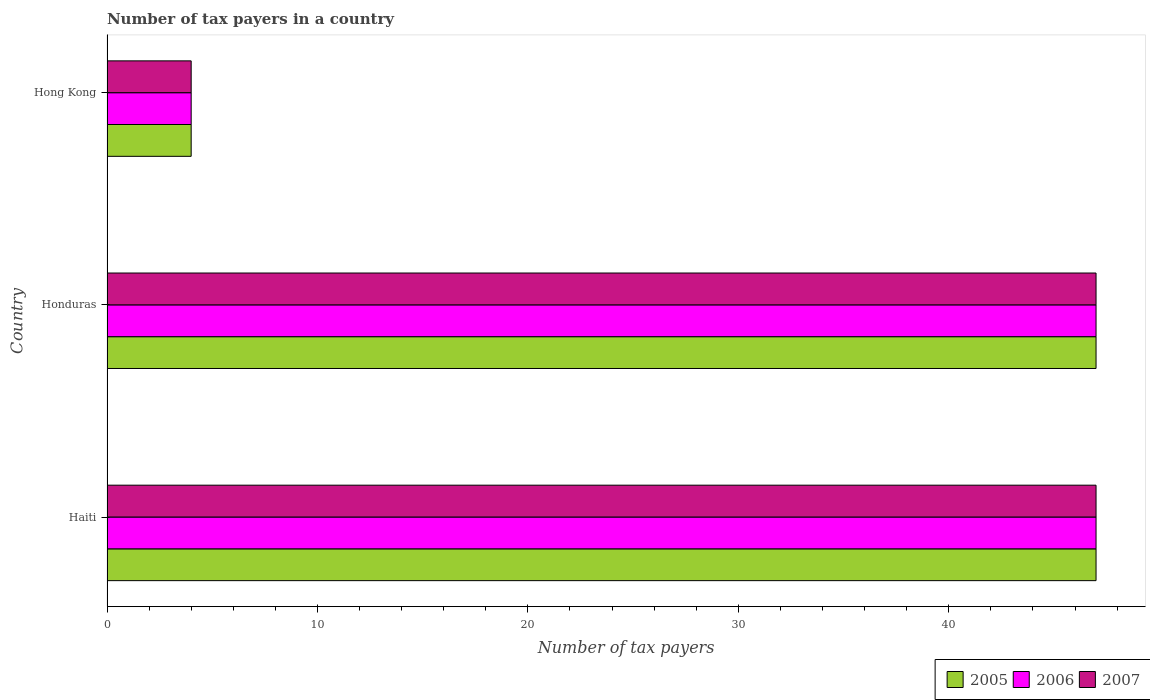How many groups of bars are there?
Provide a short and direct response. 3. Are the number of bars on each tick of the Y-axis equal?
Your answer should be very brief. Yes. How many bars are there on the 1st tick from the top?
Give a very brief answer. 3. How many bars are there on the 1st tick from the bottom?
Keep it short and to the point. 3. What is the label of the 2nd group of bars from the top?
Make the answer very short. Honduras. In how many cases, is the number of bars for a given country not equal to the number of legend labels?
Provide a succinct answer. 0. Across all countries, what is the maximum number of tax payers in in 2006?
Your answer should be very brief. 47. Across all countries, what is the minimum number of tax payers in in 2005?
Offer a very short reply. 4. In which country was the number of tax payers in in 2007 maximum?
Your answer should be compact. Haiti. In which country was the number of tax payers in in 2006 minimum?
Keep it short and to the point. Hong Kong. What is the difference between the number of tax payers in in 2006 in Haiti and that in Hong Kong?
Make the answer very short. 43. What is the difference between the number of tax payers in in 2006 in Hong Kong and the number of tax payers in in 2005 in Haiti?
Your answer should be very brief. -43. What is the average number of tax payers in in 2005 per country?
Offer a very short reply. 32.67. What is the difference between the number of tax payers in in 2006 and number of tax payers in in 2007 in Haiti?
Keep it short and to the point. 0. In how many countries, is the number of tax payers in in 2007 greater than 28 ?
Ensure brevity in your answer.  2. What is the ratio of the number of tax payers in in 2007 in Haiti to that in Hong Kong?
Your answer should be compact. 11.75. Is the number of tax payers in in 2006 in Honduras less than that in Hong Kong?
Offer a very short reply. No. Is the difference between the number of tax payers in in 2006 in Honduras and Hong Kong greater than the difference between the number of tax payers in in 2007 in Honduras and Hong Kong?
Ensure brevity in your answer.  No. What is the difference between the highest and the second highest number of tax payers in in 2005?
Your answer should be very brief. 0. Is it the case that in every country, the sum of the number of tax payers in in 2006 and number of tax payers in in 2007 is greater than the number of tax payers in in 2005?
Offer a very short reply. Yes. Are all the bars in the graph horizontal?
Give a very brief answer. Yes. What is the difference between two consecutive major ticks on the X-axis?
Offer a terse response. 10. Are the values on the major ticks of X-axis written in scientific E-notation?
Provide a succinct answer. No. Does the graph contain any zero values?
Keep it short and to the point. No. Where does the legend appear in the graph?
Offer a very short reply. Bottom right. What is the title of the graph?
Provide a short and direct response. Number of tax payers in a country. Does "1971" appear as one of the legend labels in the graph?
Offer a very short reply. No. What is the label or title of the X-axis?
Your answer should be compact. Number of tax payers. What is the label or title of the Y-axis?
Make the answer very short. Country. What is the Number of tax payers of 2005 in Haiti?
Offer a very short reply. 47. What is the Number of tax payers in 2007 in Haiti?
Give a very brief answer. 47. What is the Number of tax payers in 2005 in Honduras?
Ensure brevity in your answer.  47. What is the Number of tax payers of 2006 in Honduras?
Your answer should be very brief. 47. What is the Number of tax payers of 2006 in Hong Kong?
Ensure brevity in your answer.  4. What is the Number of tax payers of 2007 in Hong Kong?
Keep it short and to the point. 4. Across all countries, what is the maximum Number of tax payers in 2007?
Provide a succinct answer. 47. What is the total Number of tax payers in 2005 in the graph?
Provide a short and direct response. 98. What is the total Number of tax payers in 2007 in the graph?
Keep it short and to the point. 98. What is the difference between the Number of tax payers of 2005 in Haiti and that in Honduras?
Provide a short and direct response. 0. What is the difference between the Number of tax payers of 2006 in Haiti and that in Honduras?
Ensure brevity in your answer.  0. What is the difference between the Number of tax payers of 2005 in Haiti and that in Hong Kong?
Your answer should be compact. 43. What is the difference between the Number of tax payers in 2005 in Honduras and that in Hong Kong?
Your response must be concise. 43. What is the difference between the Number of tax payers of 2005 in Haiti and the Number of tax payers of 2006 in Hong Kong?
Provide a short and direct response. 43. What is the difference between the Number of tax payers of 2005 in Honduras and the Number of tax payers of 2006 in Hong Kong?
Make the answer very short. 43. What is the average Number of tax payers in 2005 per country?
Offer a very short reply. 32.67. What is the average Number of tax payers in 2006 per country?
Your answer should be very brief. 32.67. What is the average Number of tax payers of 2007 per country?
Your answer should be compact. 32.67. What is the difference between the Number of tax payers in 2005 and Number of tax payers in 2006 in Haiti?
Provide a succinct answer. 0. What is the difference between the Number of tax payers of 2006 and Number of tax payers of 2007 in Haiti?
Offer a very short reply. 0. What is the difference between the Number of tax payers of 2005 and Number of tax payers of 2007 in Honduras?
Keep it short and to the point. 0. What is the difference between the Number of tax payers in 2005 and Number of tax payers in 2007 in Hong Kong?
Ensure brevity in your answer.  0. What is the ratio of the Number of tax payers in 2005 in Haiti to that in Honduras?
Keep it short and to the point. 1. What is the ratio of the Number of tax payers of 2006 in Haiti to that in Honduras?
Offer a very short reply. 1. What is the ratio of the Number of tax payers in 2005 in Haiti to that in Hong Kong?
Provide a succinct answer. 11.75. What is the ratio of the Number of tax payers of 2006 in Haiti to that in Hong Kong?
Your response must be concise. 11.75. What is the ratio of the Number of tax payers of 2007 in Haiti to that in Hong Kong?
Provide a short and direct response. 11.75. What is the ratio of the Number of tax payers in 2005 in Honduras to that in Hong Kong?
Your response must be concise. 11.75. What is the ratio of the Number of tax payers of 2006 in Honduras to that in Hong Kong?
Your response must be concise. 11.75. What is the ratio of the Number of tax payers in 2007 in Honduras to that in Hong Kong?
Keep it short and to the point. 11.75. What is the difference between the highest and the second highest Number of tax payers in 2005?
Your answer should be very brief. 0. What is the difference between the highest and the lowest Number of tax payers of 2005?
Keep it short and to the point. 43. 